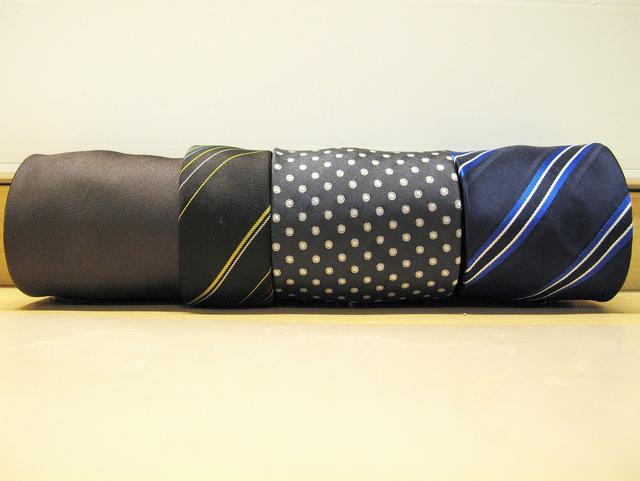Are these usually for men or women?
Be succinct. Men. What are these?
Give a very brief answer. Ties. What are these worn in conjunction with?
Short answer required. Suit. 